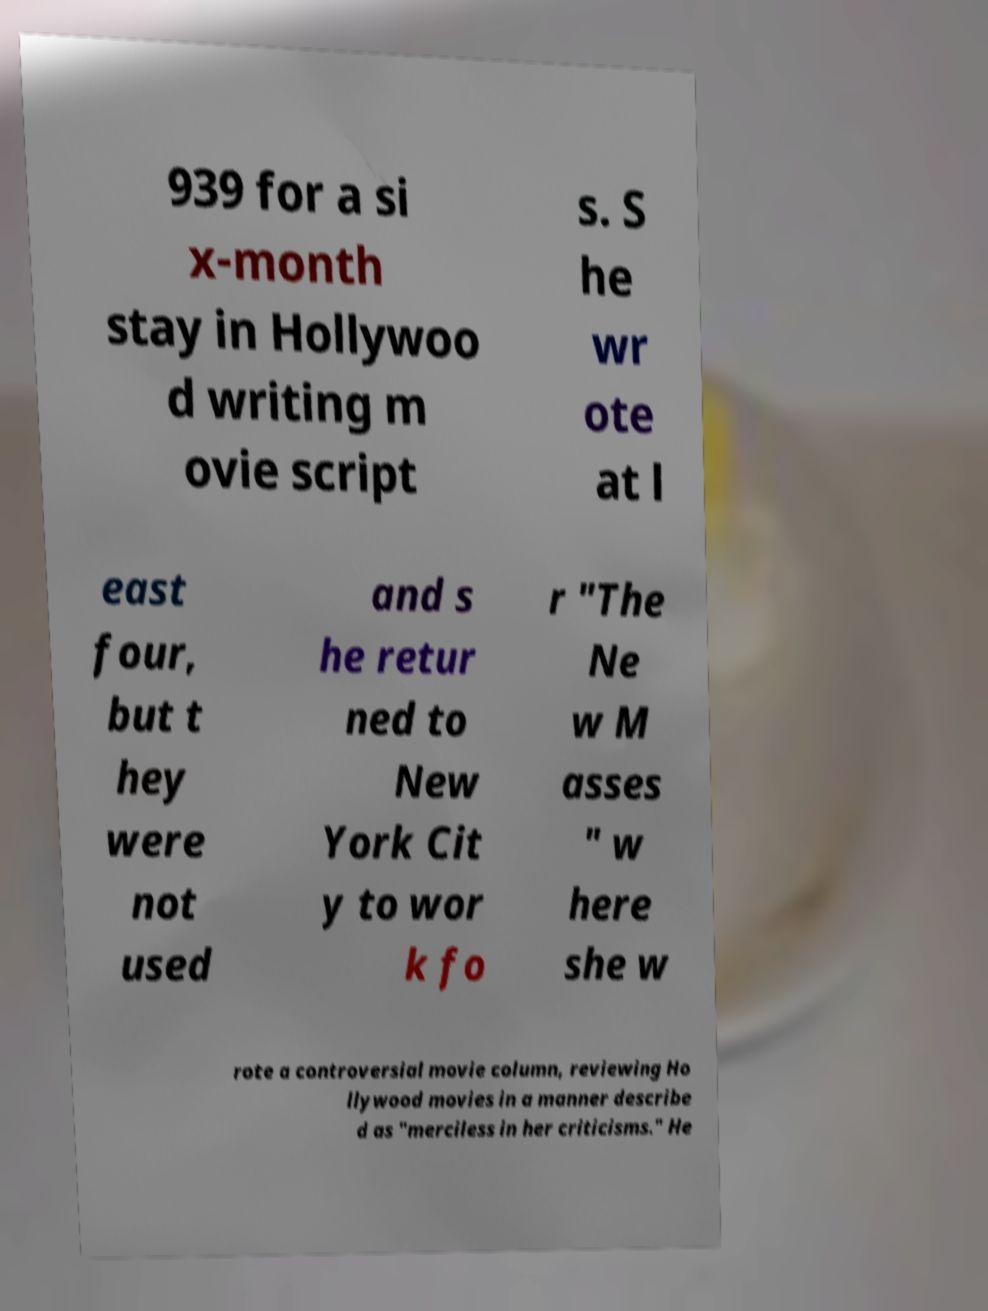Can you read and provide the text displayed in the image?This photo seems to have some interesting text. Can you extract and type it out for me? 939 for a si x-month stay in Hollywoo d writing m ovie script s. S he wr ote at l east four, but t hey were not used and s he retur ned to New York Cit y to wor k fo r "The Ne w M asses " w here she w rote a controversial movie column, reviewing Ho llywood movies in a manner describe d as "merciless in her criticisms." He 